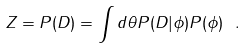Convert formula to latex. <formula><loc_0><loc_0><loc_500><loc_500>Z = P ( D ) = \int d \theta P ( D | \phi ) P ( \phi ) \ .</formula> 